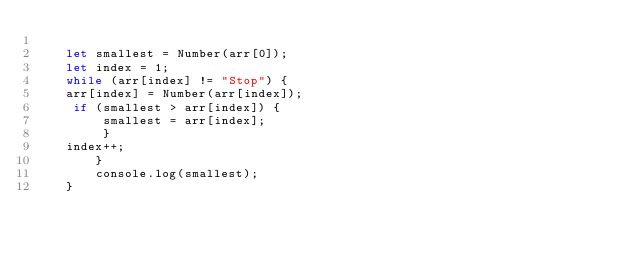Convert code to text. <code><loc_0><loc_0><loc_500><loc_500><_JavaScript_>
    let smallest = Number(arr[0]);
    let index = 1;
    while (arr[index] != "Stop") {
    arr[index] = Number(arr[index]);
     if (smallest > arr[index]) {
         smallest = arr[index];
         }
    index++;
        }
        console.log(smallest);
    }</code> 